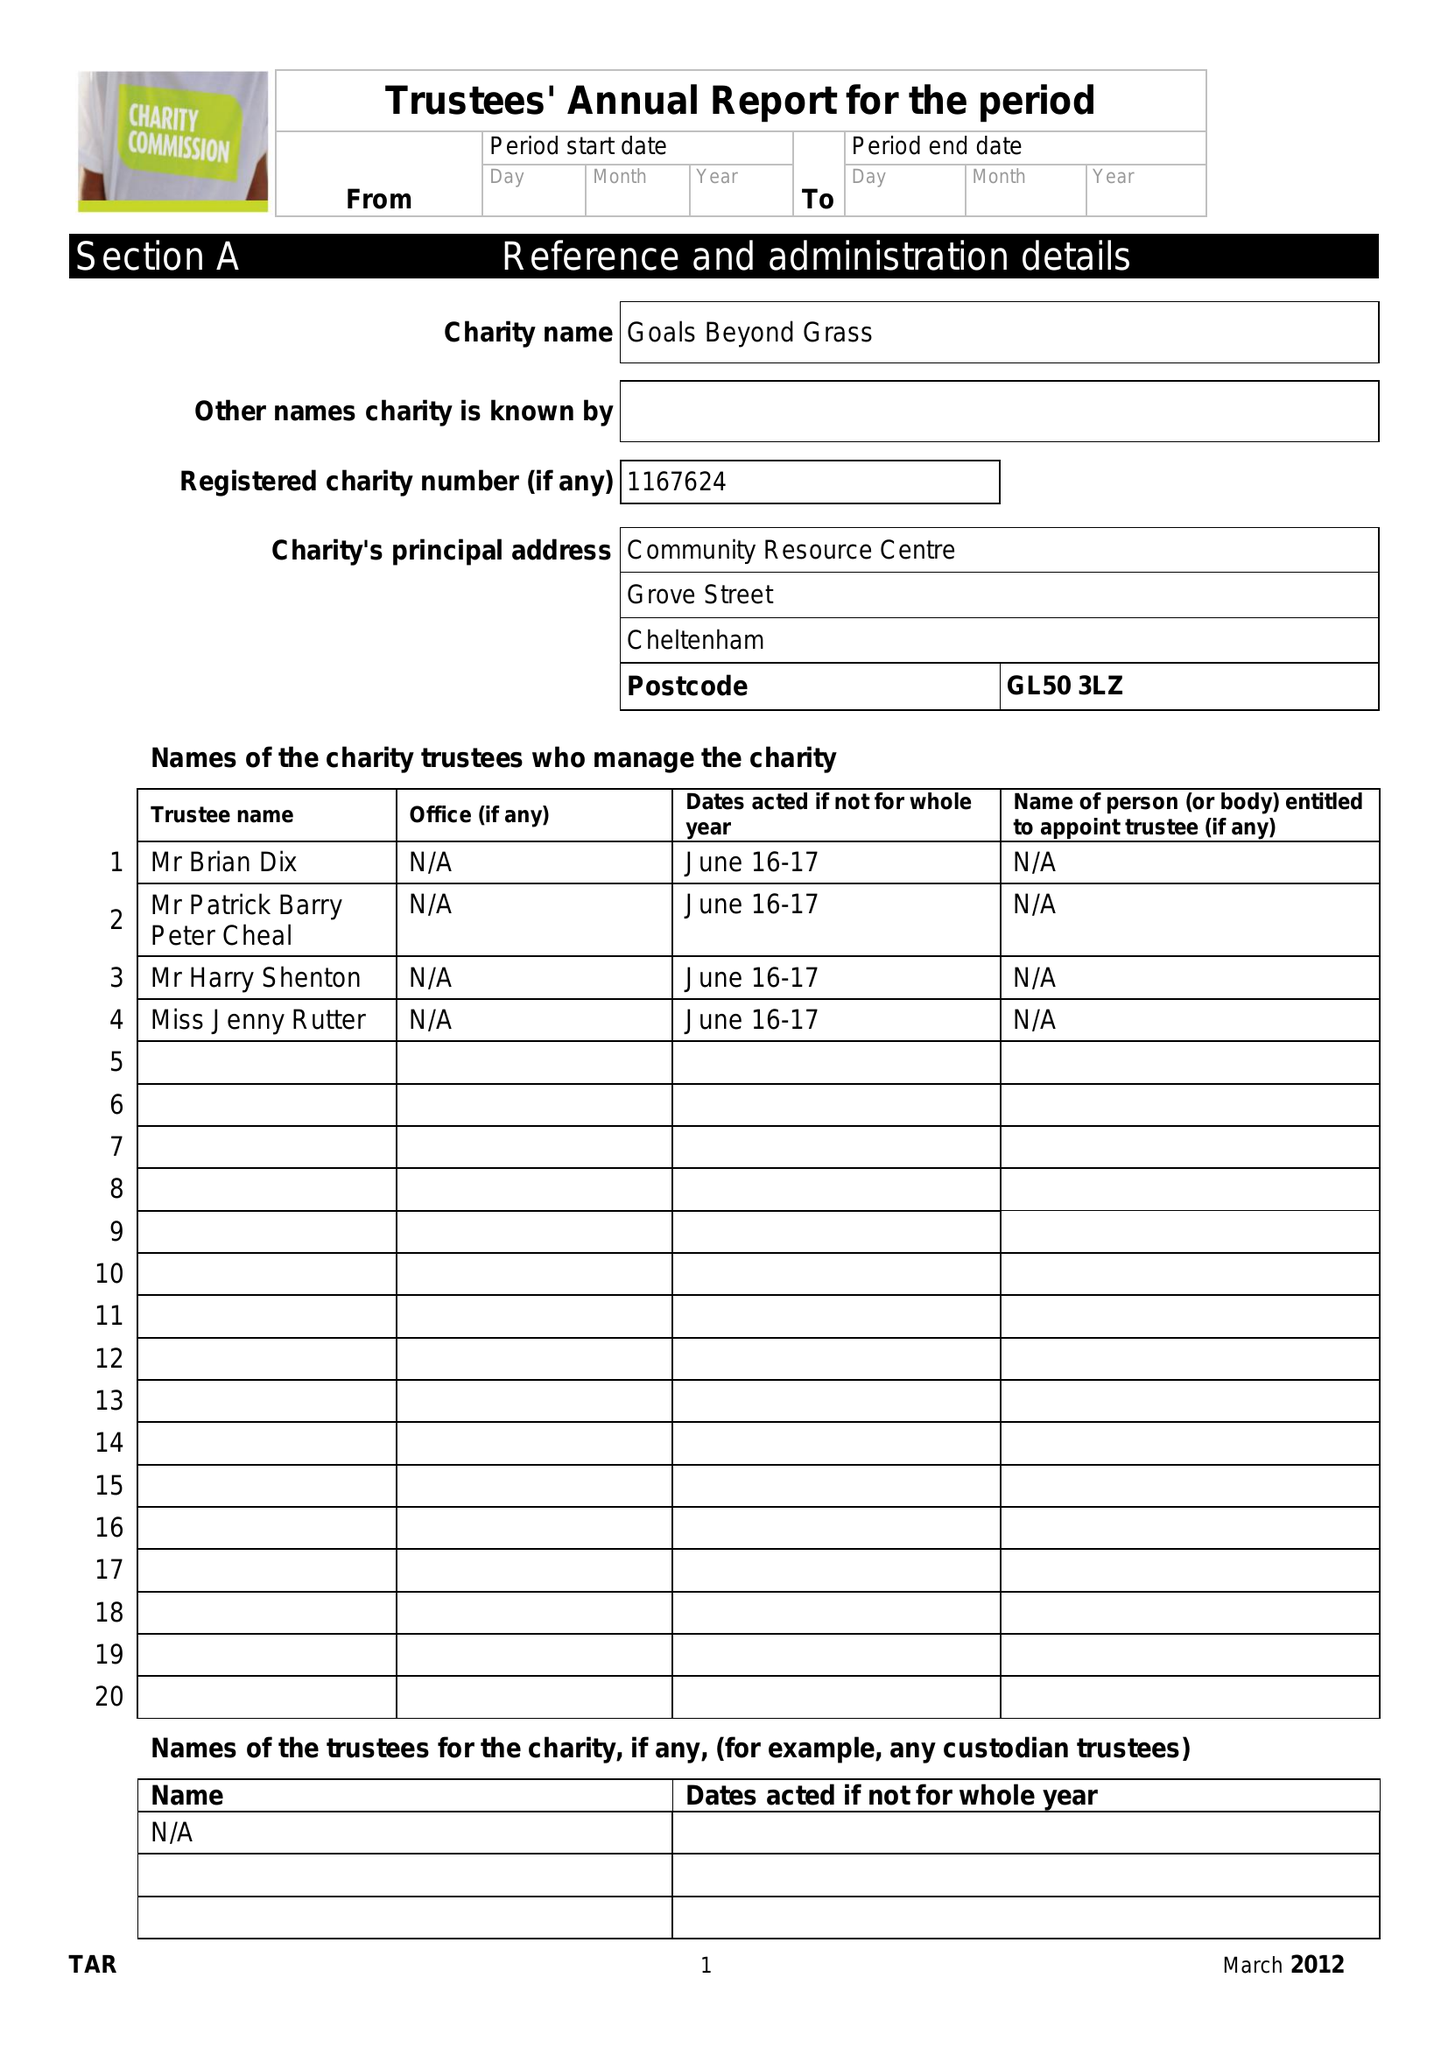What is the value for the address__street_line?
Answer the question using a single word or phrase. 40B LONDON ROAD 